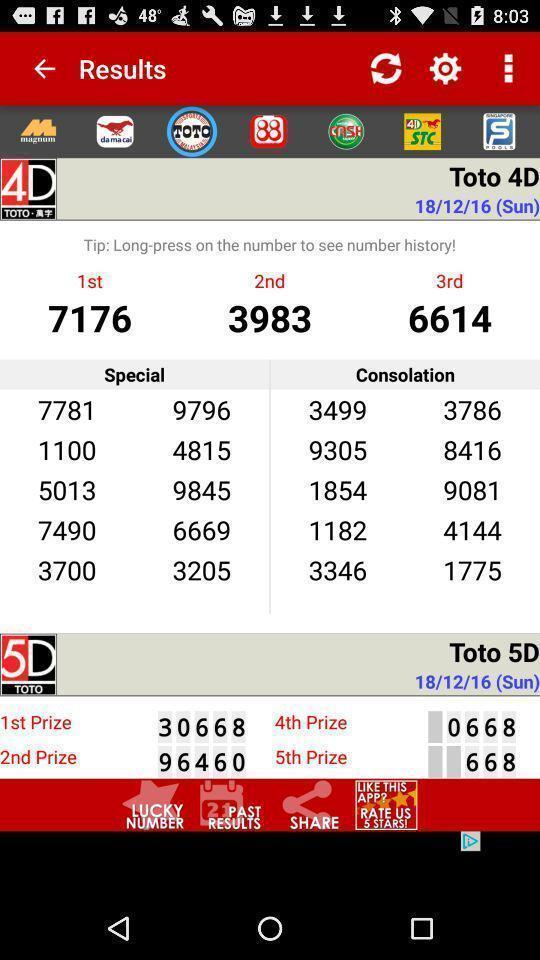What details can you identify in this image? Screen displaying results page in the app. 